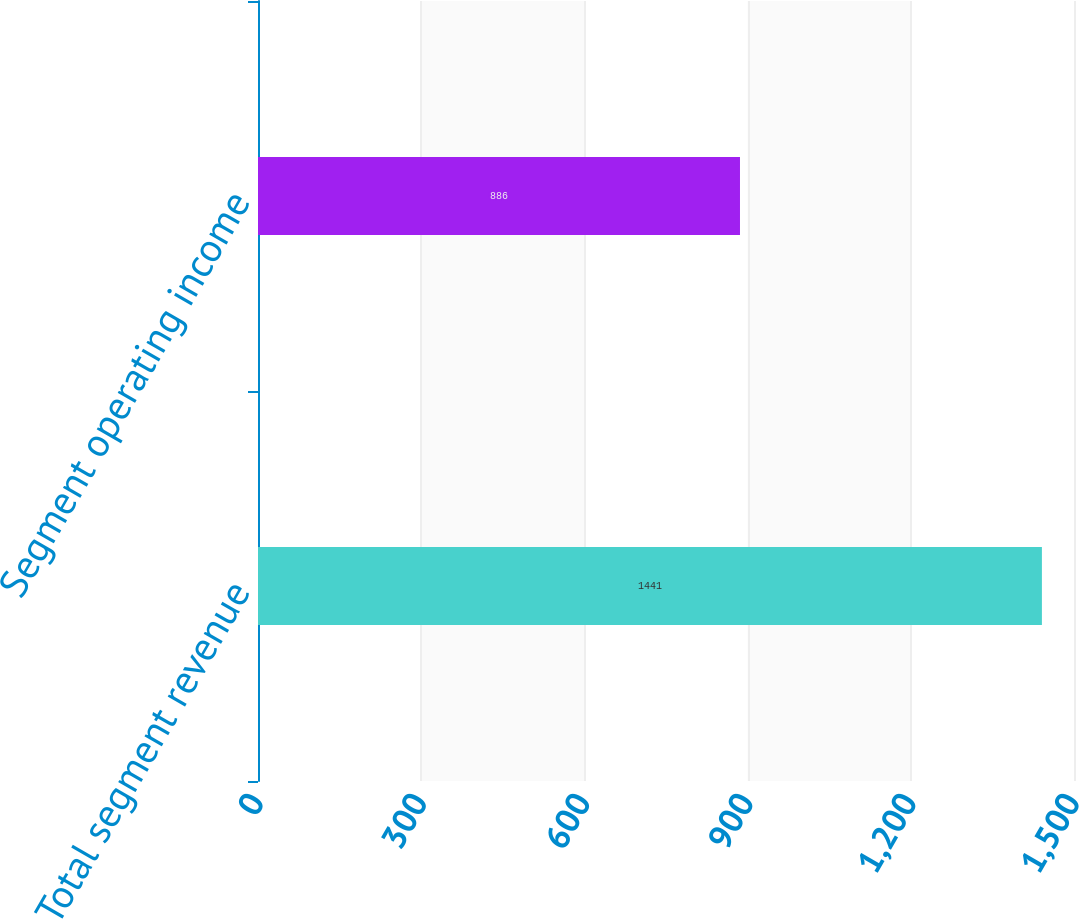Convert chart. <chart><loc_0><loc_0><loc_500><loc_500><bar_chart><fcel>Total segment revenue<fcel>Segment operating income<nl><fcel>1441<fcel>886<nl></chart> 